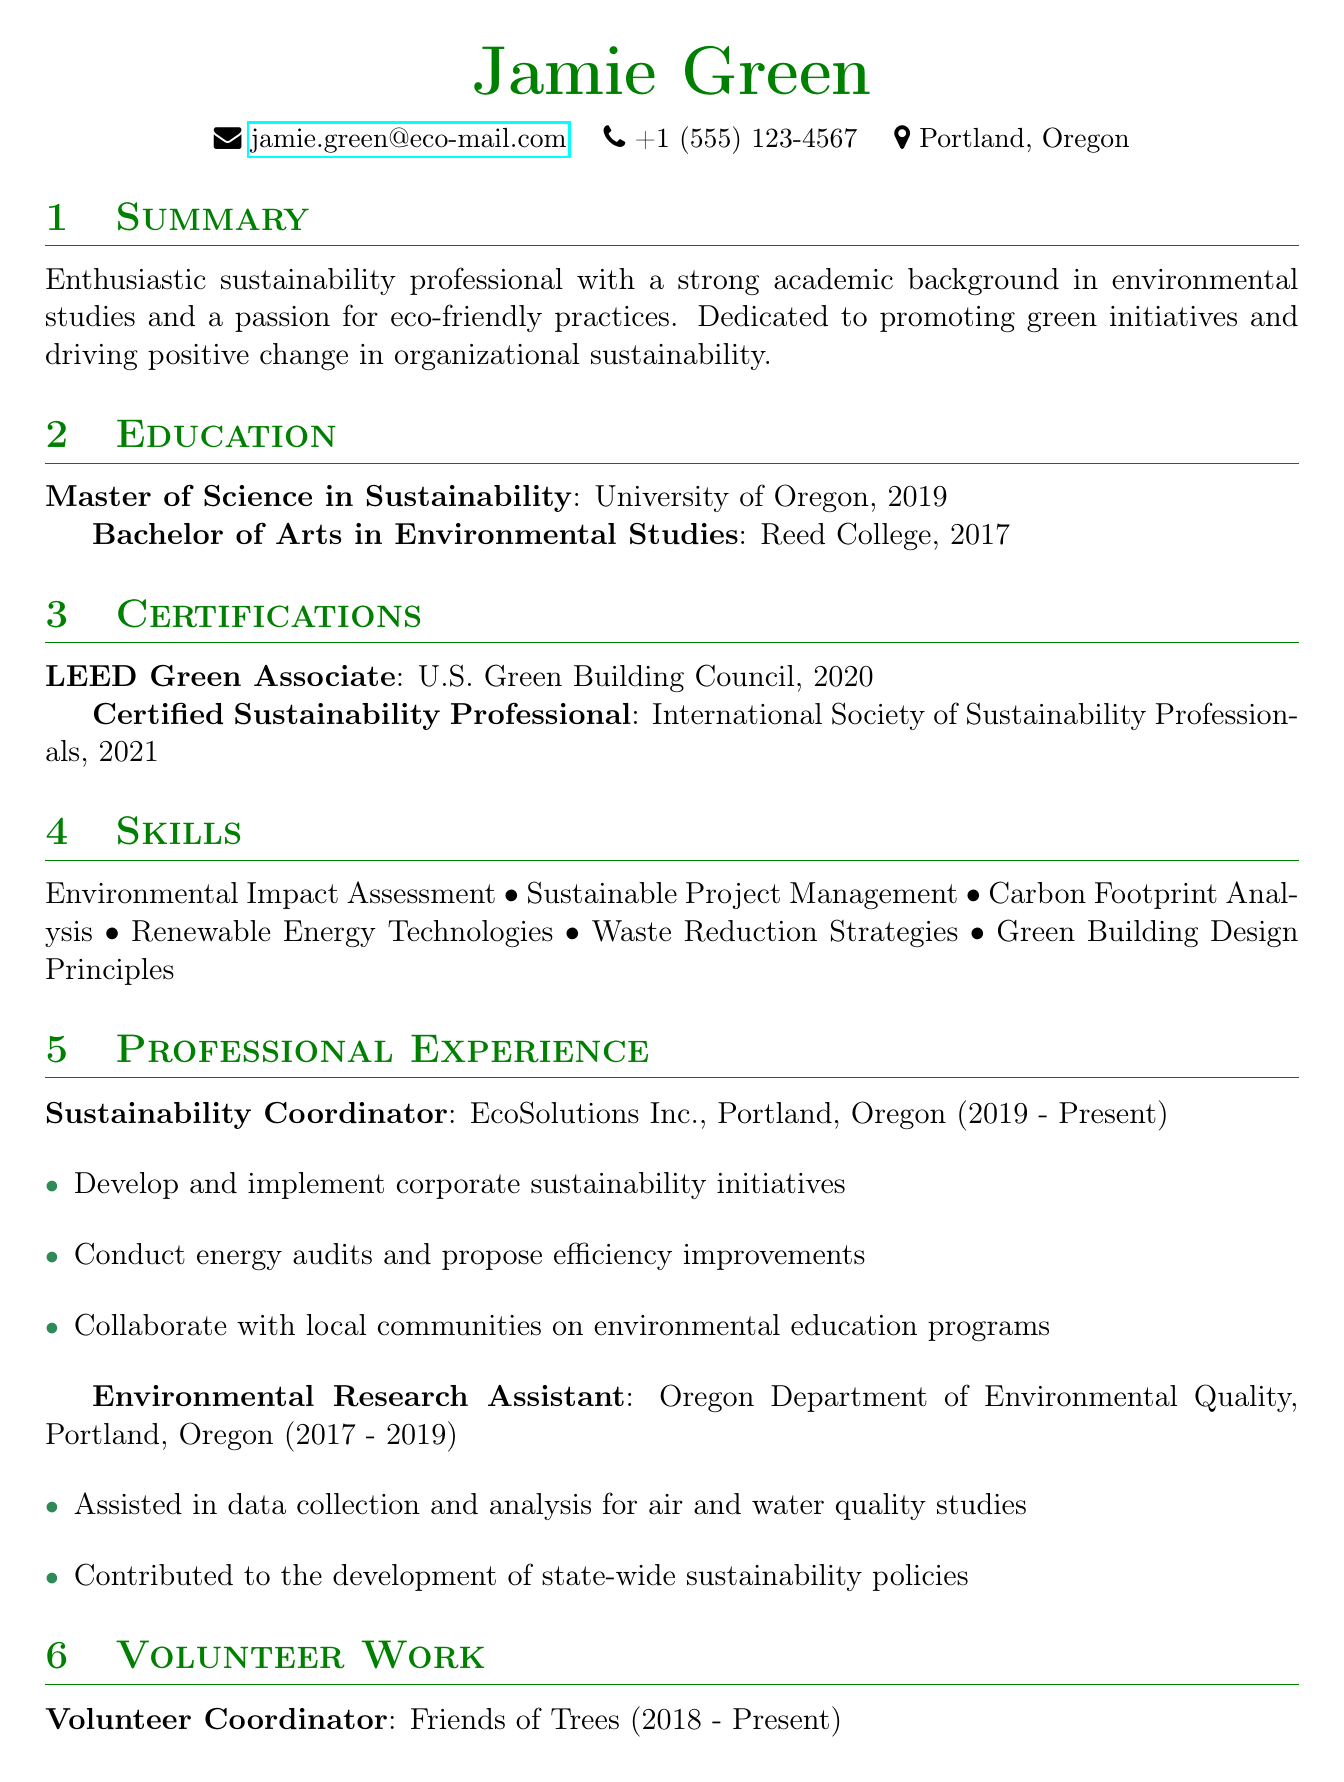what is Jamie Green's email address? The email address is listed in the personal information section of the document.
Answer: jamie.green@eco-mail.com what degree did Jamie earn in 2019? The education section indicates the degree Jamie earned in 2019.
Answer: Master of Science in Sustainability which organization issued the "LEED Green Associate" certification? This certification is detailed in the certifications section of the document.
Answer: U.S. Green Building Council how long has Jamie been working at EcoSolutions Inc.? The experience section provides the duration of the position held at EcoSolutions Inc.
Answer: 2019 - Present what is one of Jamie's responsibilities as a Sustainability Coordinator? Responsibilities under the Sustainability Coordinator role list specific duties Jamie performs.
Answer: Develop and implement corporate sustainability initiatives which university did Jamie attend for their Bachelor's degree? The education section indicates the institution where Jamie obtained their Bachelor's degree.
Answer: Reed College how many certifications does Jamie hold? The certifications section lists the total number of certifications mentioned.
Answer: 2 what role does Jamie serve at Friends of Trees? The volunteer work section specifies Jamie's title at Friends of Trees.
Answer: Volunteer Coordinator 